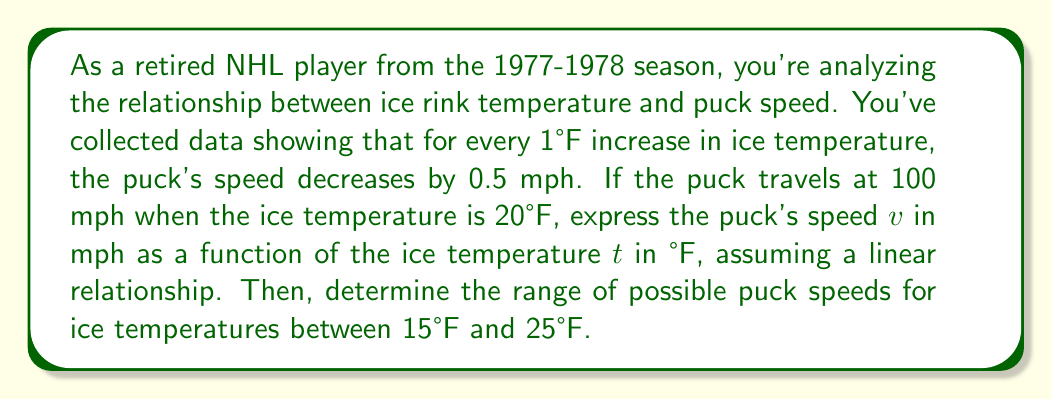Solve this math problem. Let's approach this step-by-step:

1) First, we need to establish the linear function relating puck speed to ice temperature.

   We know that:
   - At 20°F, the puck speed is 100 mph
   - For every 1°F increase, the speed decreases by 0.5 mph

2) We can express this as a linear function:
   $v = mt + b$, where $v$ is puck speed, $t$ is temperature, $m$ is the slope, and $b$ is the y-intercept.

3) We can calculate the slope:
   $m = \frac{\text{change in speed}}{\text{change in temperature}} = \frac{-0.5 \text{ mph}}{1°F} = -0.5$

4) Now we can use the point (20, 100) to find $b$:
   $100 = -0.5(20) + b$
   $100 = -10 + b$
   $b = 110$

5) Therefore, our function is:
   $v = -0.5t + 110$

6) To find the range of speeds for temperatures between 15°F and 25°F, we need to evaluate the function at these temperatures:

   At 15°F: $v = -0.5(15) + 110 = 102.5$ mph
   At 25°F: $v = -0.5(25) + 110 = 97.5$ mph

7) Therefore, the range of speeds is from 97.5 mph to 102.5 mph.

8) We can express this as an inequality:
   $97.5 \leq v \leq 102.5$
Answer: The function relating puck speed to ice temperature is $v = -0.5t + 110$, where $v$ is in mph and $t$ is in °F. The range of possible puck speeds for ice temperatures between 15°F and 25°F is $97.5 \leq v \leq 102.5$ mph. 